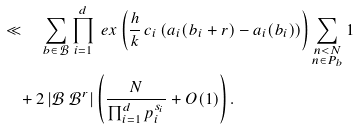Convert formula to latex. <formula><loc_0><loc_0><loc_500><loc_500>& \ll \quad \sum _ { b \in \mathcal { B } } \prod _ { i = 1 } ^ { d } \ e x \left ( \frac { h } { k } \, c _ { i } \left ( a _ { i } ( b _ { i } + r ) - a _ { i } ( b _ { i } ) \right ) \right ) \sum _ { \substack { n < N \\ n \in P _ { b } } } 1 \\ & \quad + 2 \, | \mathcal { B } \ \mathcal { B } ^ { r } | \left ( \frac { N } { \prod _ { i = 1 } ^ { d } p _ { i } ^ { s _ { i } } } + O ( 1 ) \right ) .</formula> 